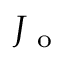Convert formula to latex. <formula><loc_0><loc_0><loc_500><loc_500>J _ { o }</formula> 